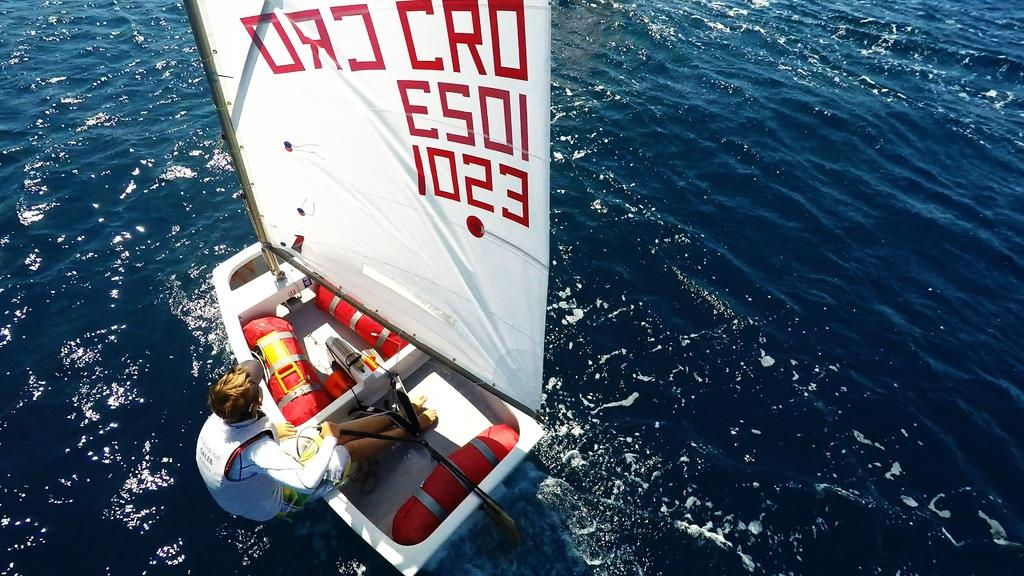Who is present in the image? There is a person in the image. What is the person doing in the image? The person is sitting on a boat. What type of tools does the carpenter have on the boat in the image? There is no carpenter or tools present in the image; it only shows a person sitting on a boat. 